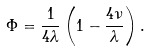Convert formula to latex. <formula><loc_0><loc_0><loc_500><loc_500>\Phi = \frac { 1 } { 4 \lambda } \left ( 1 - \frac { 4 \nu } { \lambda } \right ) .</formula> 